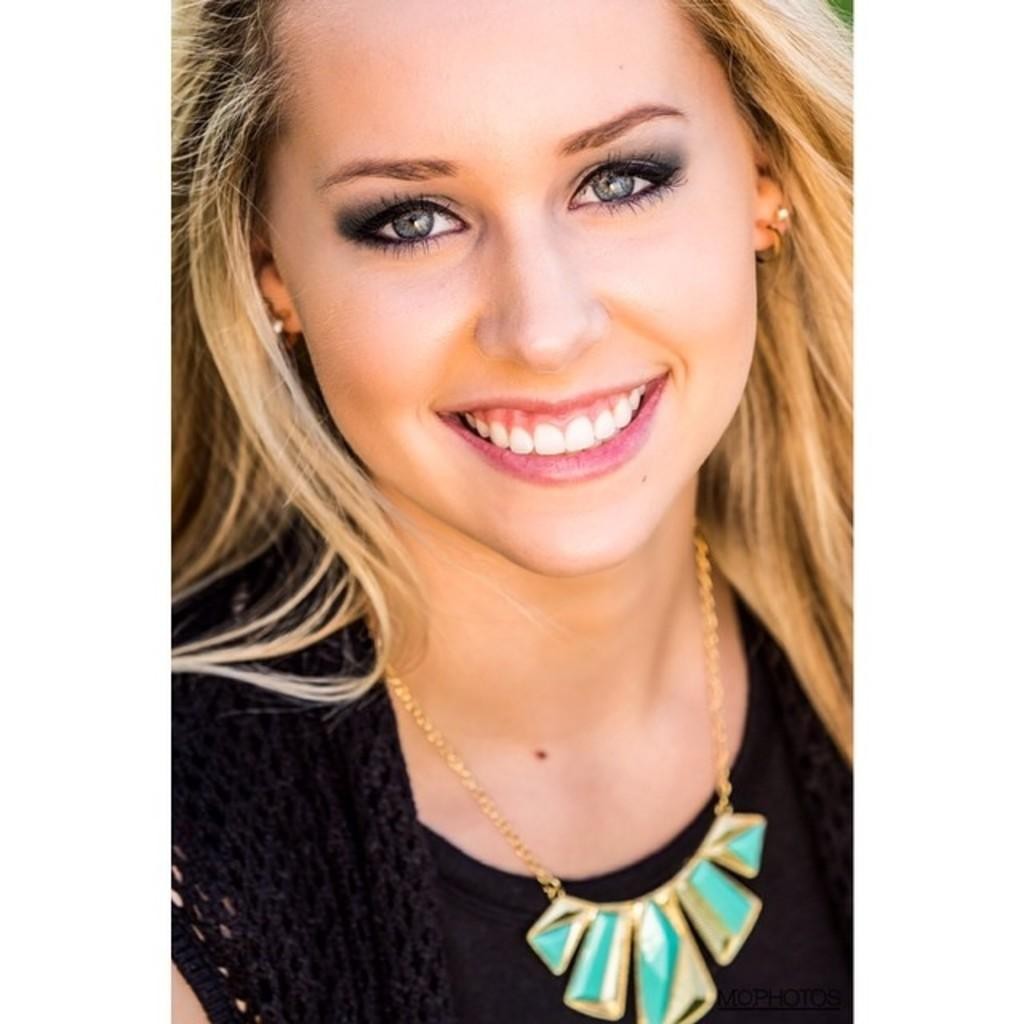What is the main subject of the image? There is a woman in the image. What is the woman wearing? The woman is wearing a black dress. What is the woman's facial expression in the image? The woman is smiling. What type of sky can be seen in the image? There is no sky visible in the image; it only features a woman wearing a black dress and smiling. 